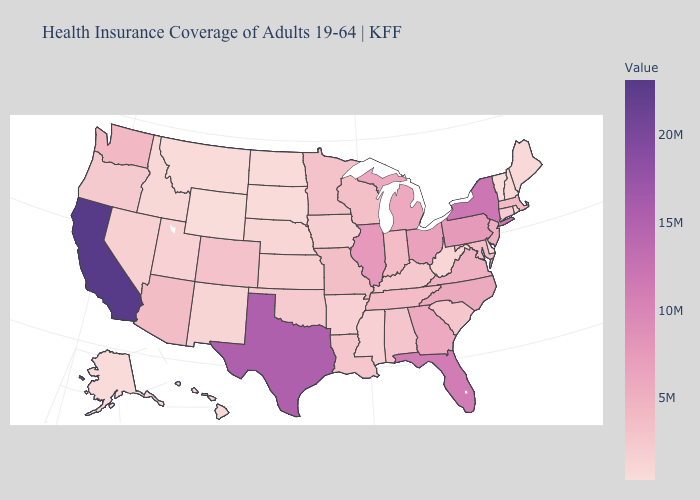Does Wyoming have the lowest value in the USA?
Give a very brief answer. Yes. 